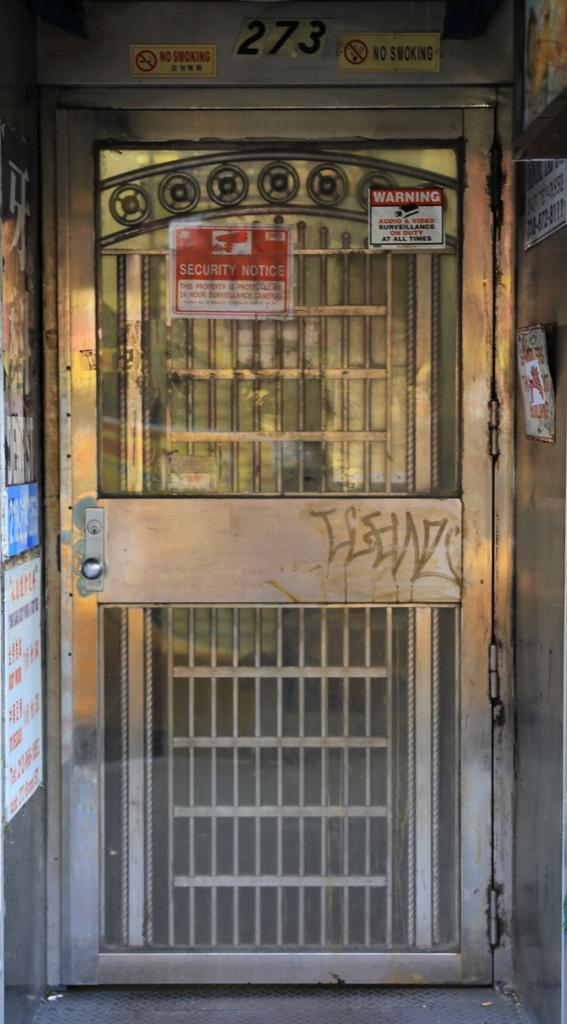What is the main object in the image? There is a door in the image. What is attached to the door? Boards are attached to the door. Are there any other boards visible in the image? Yes, there are additional boards on both sides of the door. What type of muscle can be seen flexing on the door in the image? There is no muscle visible on the door in the image. 